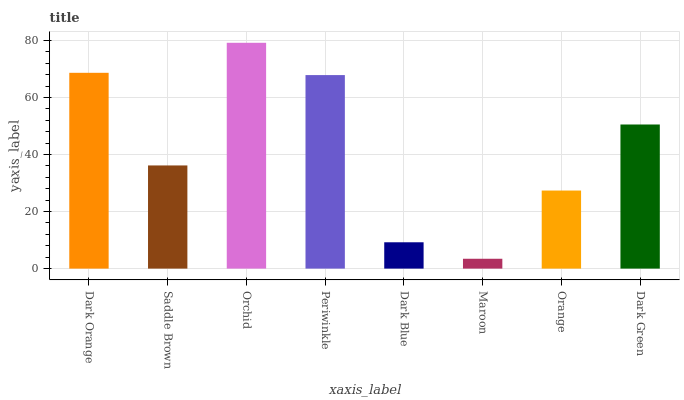Is Maroon the minimum?
Answer yes or no. Yes. Is Orchid the maximum?
Answer yes or no. Yes. Is Saddle Brown the minimum?
Answer yes or no. No. Is Saddle Brown the maximum?
Answer yes or no. No. Is Dark Orange greater than Saddle Brown?
Answer yes or no. Yes. Is Saddle Brown less than Dark Orange?
Answer yes or no. Yes. Is Saddle Brown greater than Dark Orange?
Answer yes or no. No. Is Dark Orange less than Saddle Brown?
Answer yes or no. No. Is Dark Green the high median?
Answer yes or no. Yes. Is Saddle Brown the low median?
Answer yes or no. Yes. Is Dark Blue the high median?
Answer yes or no. No. Is Maroon the low median?
Answer yes or no. No. 